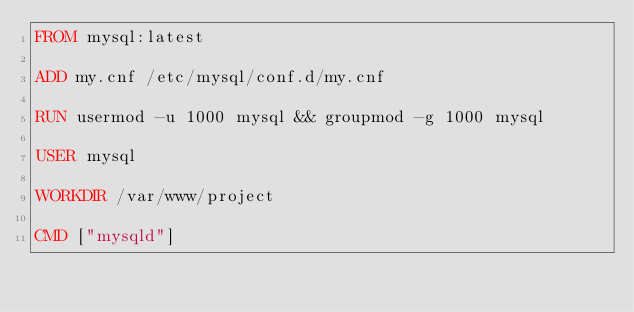Convert code to text. <code><loc_0><loc_0><loc_500><loc_500><_Dockerfile_>FROM mysql:latest

ADD my.cnf /etc/mysql/conf.d/my.cnf

RUN usermod -u 1000 mysql && groupmod -g 1000 mysql

USER mysql

WORKDIR /var/www/project

CMD ["mysqld"]
</code> 